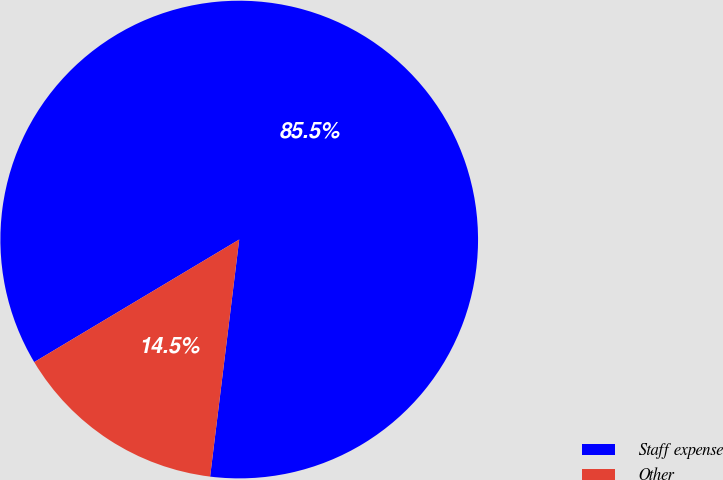<chart> <loc_0><loc_0><loc_500><loc_500><pie_chart><fcel>Staff expense<fcel>Other<nl><fcel>85.52%<fcel>14.48%<nl></chart> 